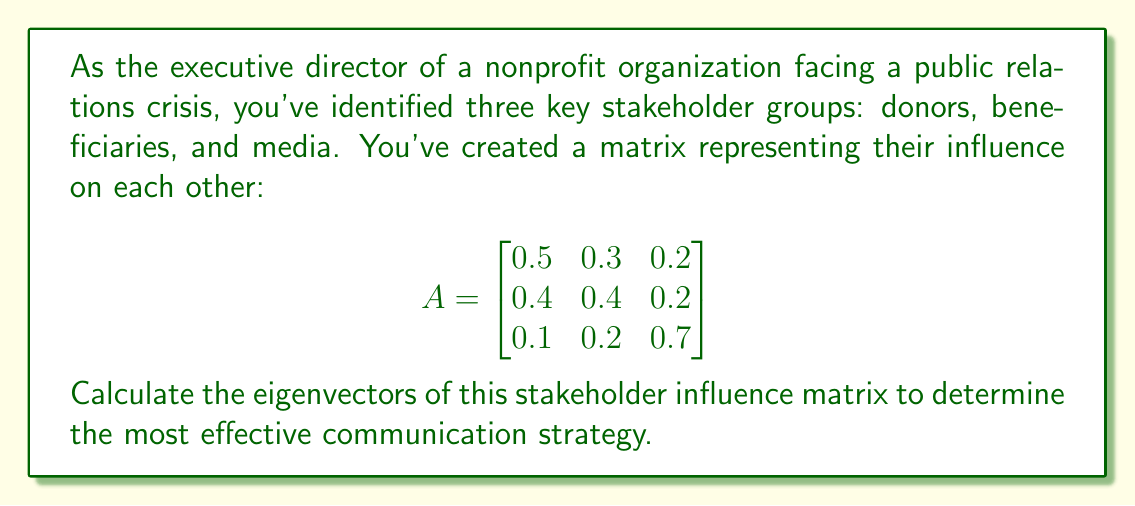Provide a solution to this math problem. To find the eigenvectors, we follow these steps:

1) First, we need to find the eigenvalues by solving the characteristic equation:
   $det(A - \lambda I) = 0$

2) Expand the determinant:
   $$\begin{vmatrix}
   0.5-\lambda & 0.3 & 0.2 \\
   0.4 & 0.4-\lambda & 0.2 \\
   0.1 & 0.2 & 0.7-\lambda
   \end{vmatrix} = 0$$

3) Solve the resulting cubic equation:
   $-\lambda^3 + 1.6\lambda^2 - 0.71\lambda + 0.1 = 0$

4) The eigenvalues are approximately $\lambda_1 \approx 1, \lambda_2 \approx 0.5, \lambda_3 \approx 0.1$

5) For each eigenvalue, solve $(A - \lambda I)v = 0$ to find the corresponding eigenvector:

   For $\lambda_1 = 1$:
   $$\begin{bmatrix}
   -0.5 & 0.3 & 0.2 \\
   0.4 & -0.6 & 0.2 \\
   0.1 & 0.2 & -0.3
   \end{bmatrix}\begin{bmatrix}v_1 \\ v_2 \\ v_3\end{bmatrix} = \begin{bmatrix}0 \\ 0 \\ 0\end{bmatrix}$$
   
   Solving this gives $v_1 \approx [0.7071, 0.5774, 0.4082]^T$

   Repeat this process for $\lambda_2$ and $\lambda_3$ to find $v_2$ and $v_3$.

6) The eigenvectors are the columns of the matrix:
   $$V \approx \begin{bmatrix}
   0.7071 & -0.6124 & -0.3536 \\
   0.5774 & 0.7906 & -0.2041 \\
   0.4082 & -0.0124 & 0.9129
   \end{bmatrix}$$

These eigenvectors represent the principal components of stakeholder influence in your crisis communication strategy.
Answer: $V \approx \begin{bmatrix}
0.7071 & -0.6124 & -0.3536 \\
0.5774 & 0.7906 & -0.2041 \\
0.4082 & -0.0124 & 0.9129
\end{bmatrix}$ 